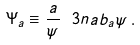<formula> <loc_0><loc_0><loc_500><loc_500>\Psi _ { a } \equiv \frac { a } { \psi } \ 3 n a b _ { a } \psi \, .</formula> 